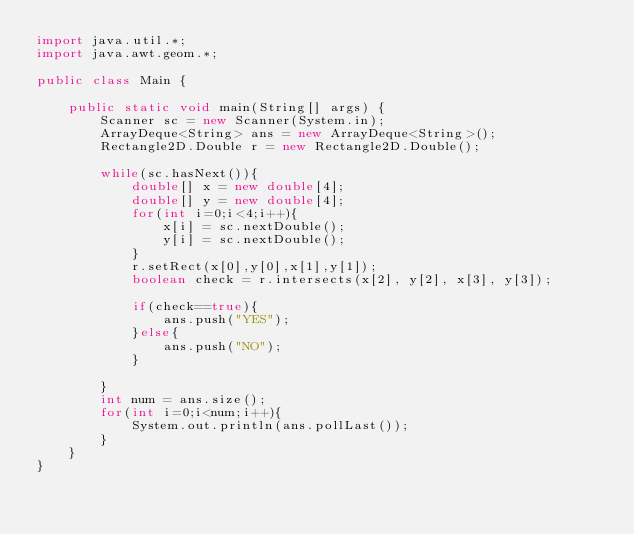<code> <loc_0><loc_0><loc_500><loc_500><_Java_>import java.util.*;
import java.awt.geom.*;

public class Main {

	public static void main(String[] args) {
		Scanner sc = new Scanner(System.in);
		ArrayDeque<String> ans = new ArrayDeque<String>();
		Rectangle2D.Double r = new Rectangle2D.Double();

		while(sc.hasNext()){
			double[] x = new double[4];
			double[] y = new double[4];
			for(int i=0;i<4;i++){			
				x[i] = sc.nextDouble();
				y[i] = sc.nextDouble();
			}
			r.setRect(x[0],y[0],x[1],y[1]);
			boolean check = r.intersects(x[2], y[2], x[3], y[3]);
			
			if(check==true){
				ans.push("YES");
			}else{
				ans.push("NO");
			}
			
		}
		int num = ans.size();
		for(int i=0;i<num;i++){
			System.out.println(ans.pollLast());
		}
	}
}</code> 